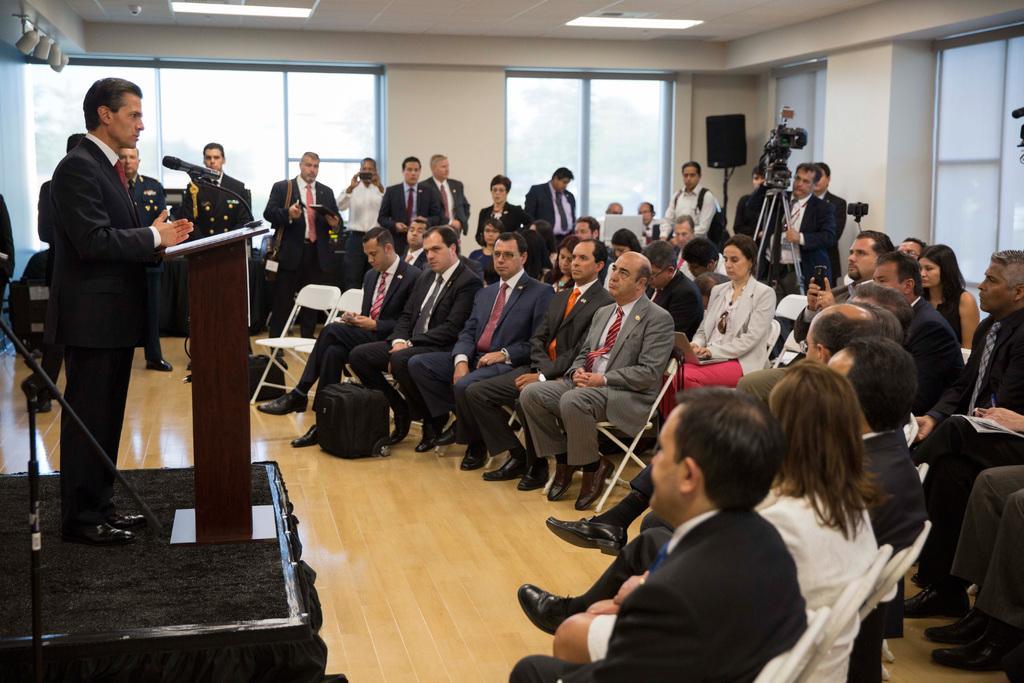Please provide a concise description of this image. In this image, we can see a person standing on stage in front of a podium and we can see a mic. In the background, there are many people sitting on chairs and some are standing and holding mobiles in their hands and we can see windows and lights. At the bottom, there is floor. 